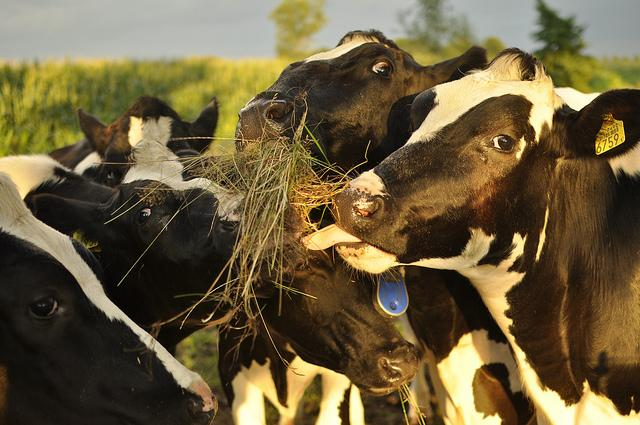What are the animals eating? Please explain your reasoning. grass. There is green grass hanging out of their mouths. 